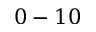<formula> <loc_0><loc_0><loc_500><loc_500>0 - 1 0</formula> 